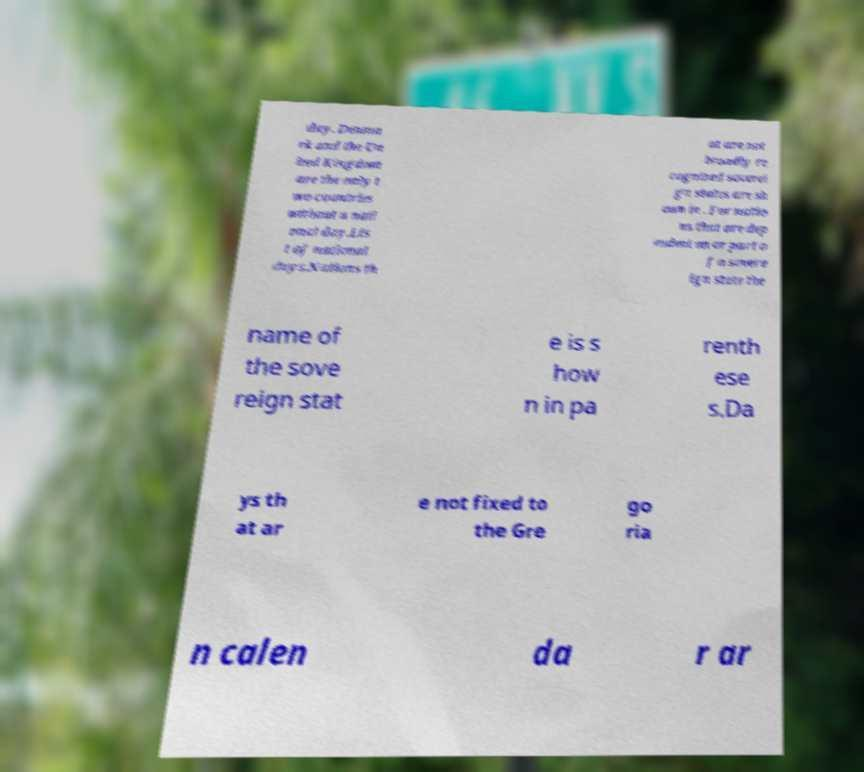Can you accurately transcribe the text from the provided image for me? day. Denma rk and the Un ited Kingdom are the only t wo countries without a nati onal day.Lis t of national days.Nations th at are not broadly re cognized soverei gn states are sh own in . For natio ns that are dep endent on or part o f a sovere ign state the name of the sove reign stat e is s how n in pa renth ese s.Da ys th at ar e not fixed to the Gre go ria n calen da r ar 